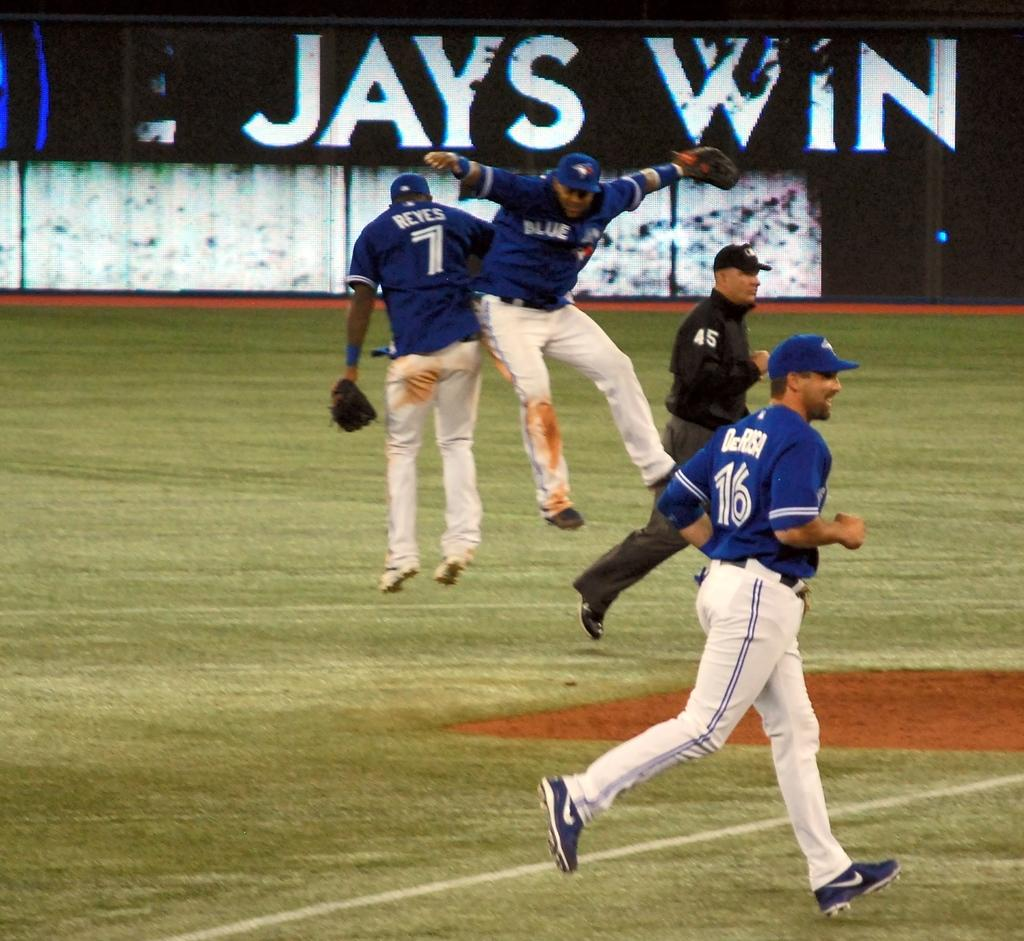<image>
Render a clear and concise summary of the photo. Several baseball players infront of a "Jays win" sign 